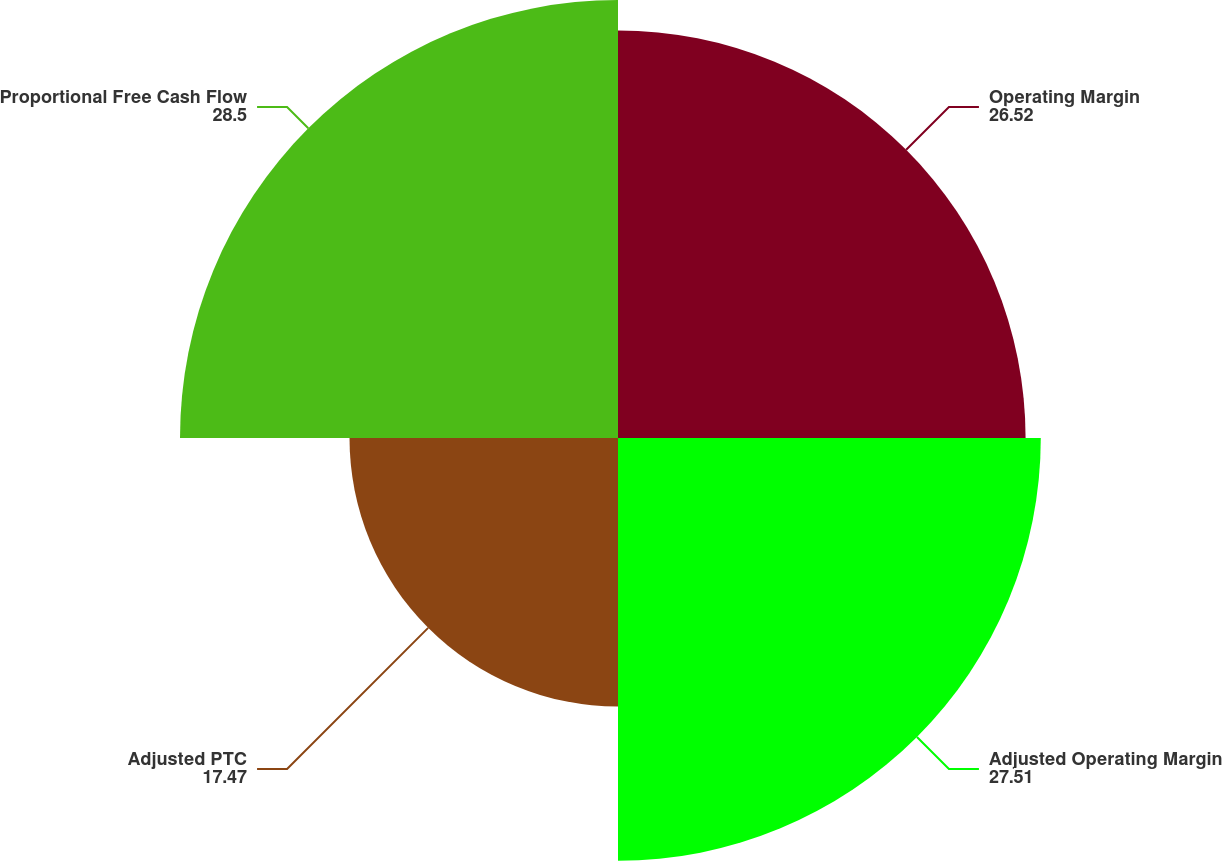<chart> <loc_0><loc_0><loc_500><loc_500><pie_chart><fcel>Operating Margin<fcel>Adjusted Operating Margin<fcel>Adjusted PTC<fcel>Proportional Free Cash Flow<nl><fcel>26.52%<fcel>27.51%<fcel>17.47%<fcel>28.5%<nl></chart> 